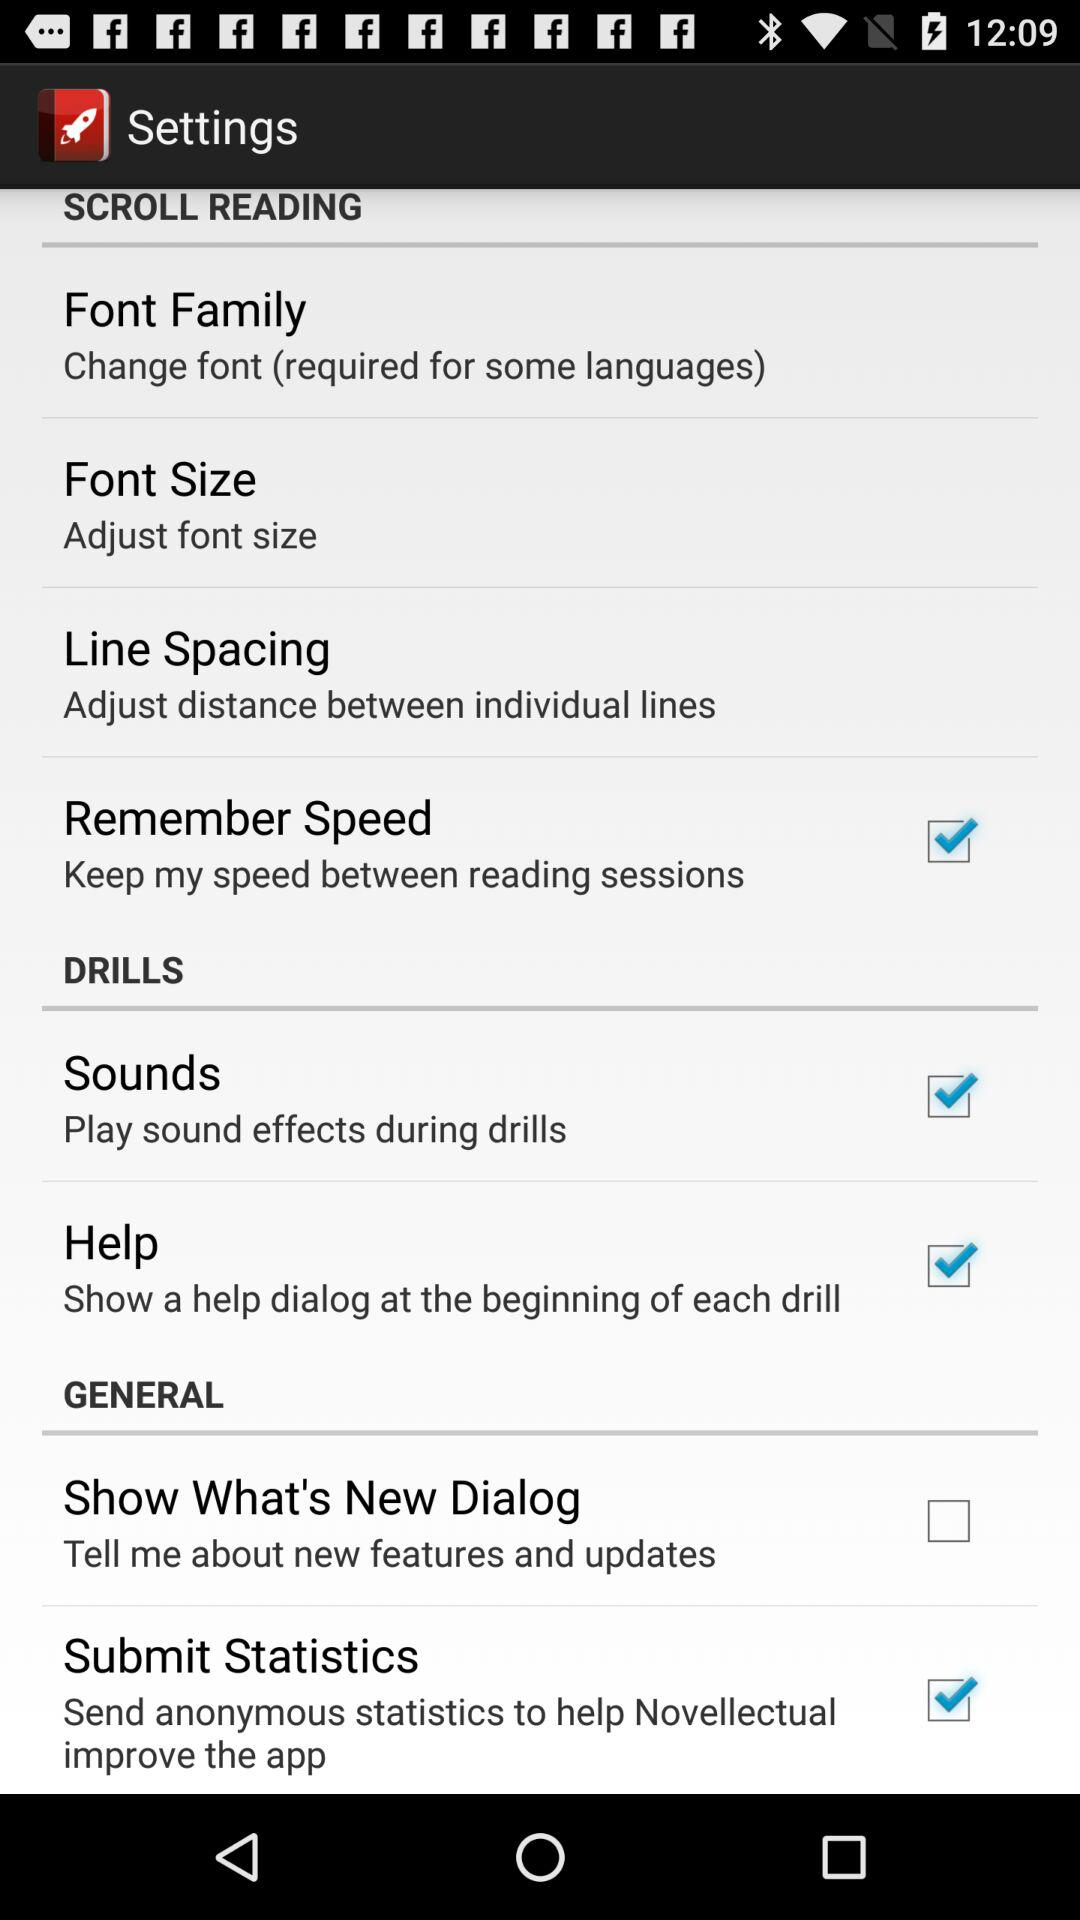What is the status of the "Submit Statistics"? The status of the "Submit Statistics" is "on". 